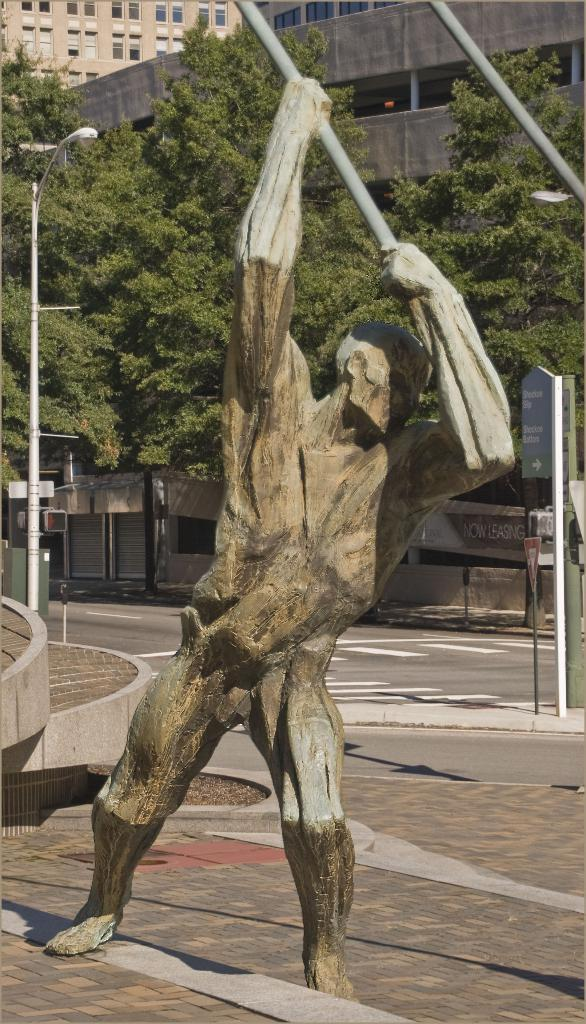What is the main subject in the image? There is a statue in the image. What can be seen in the background of the image? In the background of the image, there is a light pole, buildings, trees, signboards, stores, and hoarding. Can you describe the buildings in the background? The buildings in the background have windows. How long does it take for the gun to be fired in the image? There is no gun present in the image, so it is not possible to determine how long it would take to fire one. 